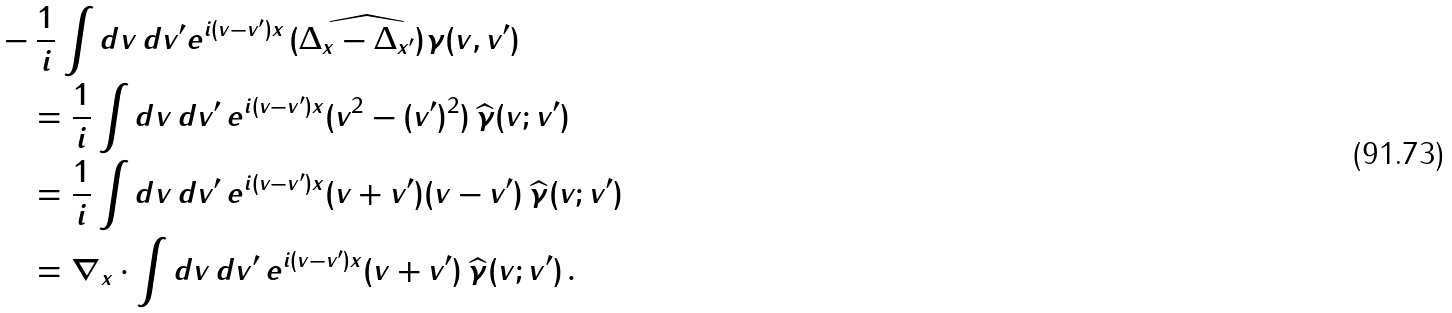<formula> <loc_0><loc_0><loc_500><loc_500>& - \frac { 1 } { i } \int d v \, d v ^ { \prime } e ^ { i ( v - v ^ { \prime } ) x } \, \widehat { ( \Delta _ { x } - \Delta _ { x ^ { \prime } } ) \gamma } ( v , v ^ { \prime } ) \\ & \quad = \frac { 1 } { i } \int d v \, d v ^ { \prime } \, e ^ { i ( v - v ^ { \prime } ) x } ( v ^ { 2 } - ( v ^ { \prime } ) ^ { 2 } ) \, \widehat { \gamma } ( v ; v ^ { \prime } ) \\ & \quad = \frac { 1 } { i } \int d v \, d v ^ { \prime } \, e ^ { i ( v - v ^ { \prime } ) x } ( v + v ^ { \prime } ) ( v - v ^ { \prime } ) \, \widehat { \gamma } ( v ; v ^ { \prime } ) \\ & \quad = \nabla _ { x } \cdot \int d v \, d v ^ { \prime } \, e ^ { i ( v - v ^ { \prime } ) x } ( v + v ^ { \prime } ) \, \widehat { \gamma } ( v ; v ^ { \prime } ) \, .</formula> 